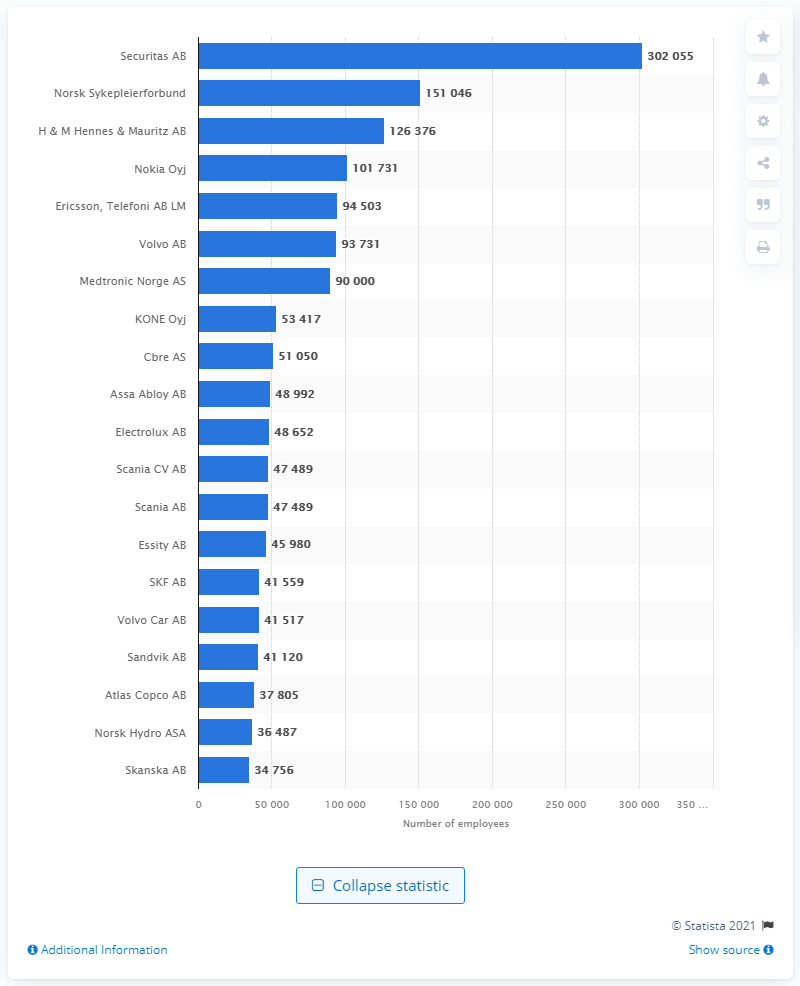List a handful of essential elements in this visual. According to the information available as of February 2021, the Swedish company with the highest number of employees in the Nordic countries is Securitas AB. As of February 2021, Securitas had a total of 302,055 employees. The second largest employer in the Nordic countries was Norsk Sykepleierforbund. 